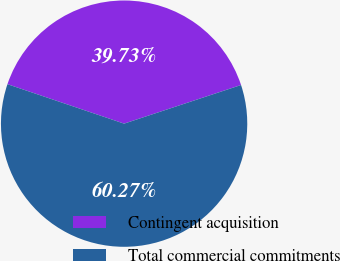<chart> <loc_0><loc_0><loc_500><loc_500><pie_chart><fcel>Contingent acquisition<fcel>Total commercial commitments<nl><fcel>39.73%<fcel>60.27%<nl></chart> 